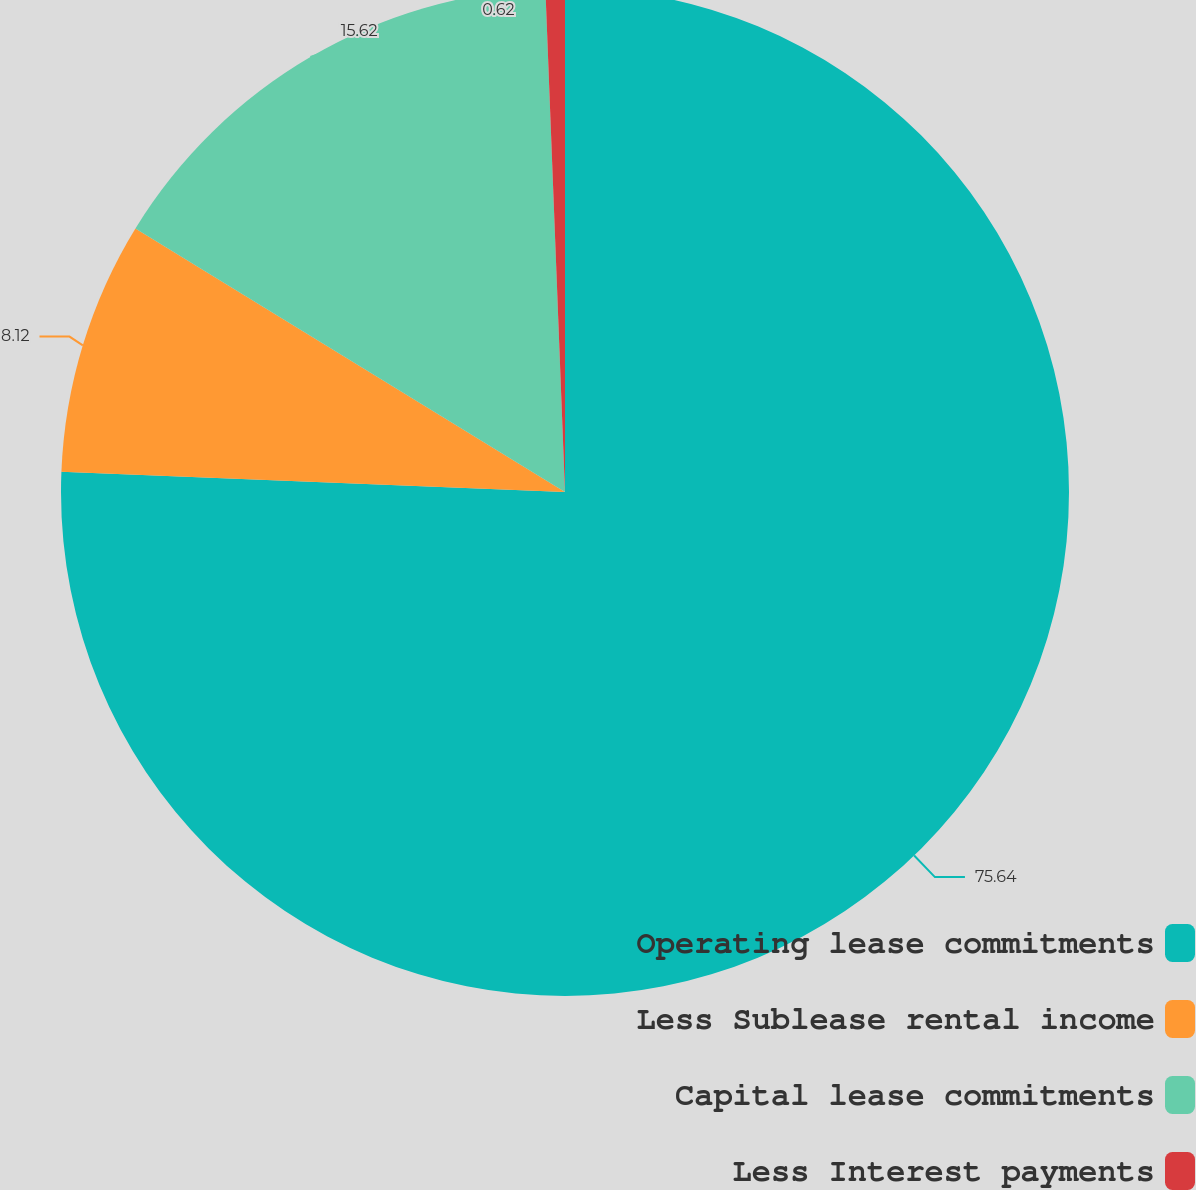Convert chart. <chart><loc_0><loc_0><loc_500><loc_500><pie_chart><fcel>Operating lease commitments<fcel>Less Sublease rental income<fcel>Capital lease commitments<fcel>Less Interest payments<nl><fcel>75.64%<fcel>8.12%<fcel>15.62%<fcel>0.62%<nl></chart> 